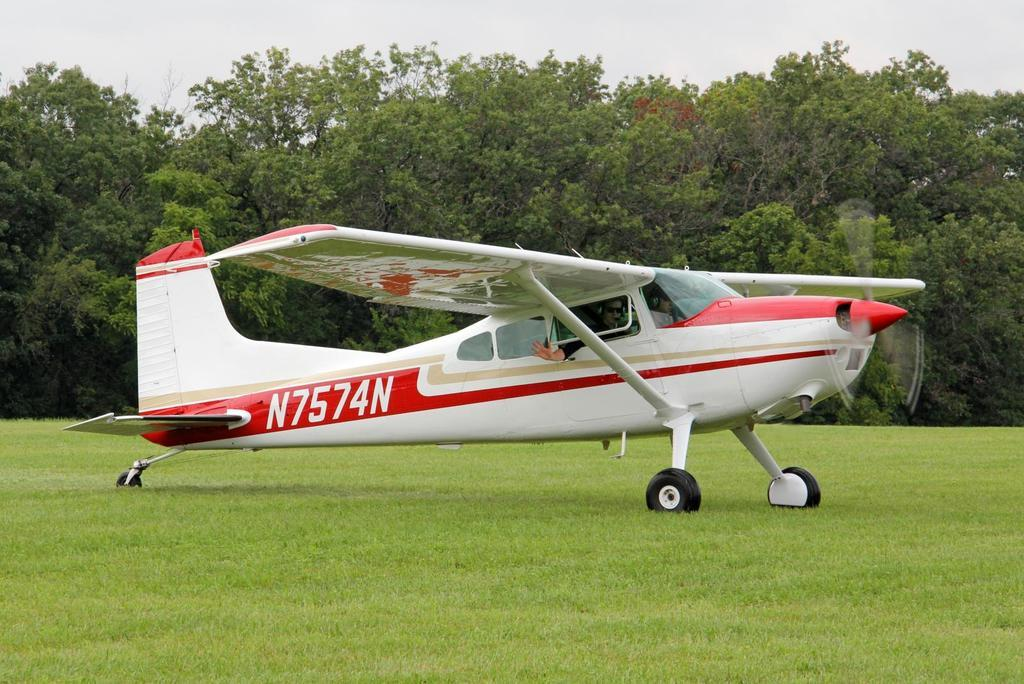What type of vegetation can be seen in the image? There is grass in the image. What is the person in the image doing? The person is sitting in the image. Where is the person sitting? The person is sitting in a plain area. What else can be seen in the image besides the person and grass? There are trees in the image. What is visible in the background of the image? The sky is visible in the image. What type of fiction is the person reading in the image? There is no book or any indication of reading in the image. What business is the person conducting in the image? There is no business activity depicted in the image; the person is simply sitting. 